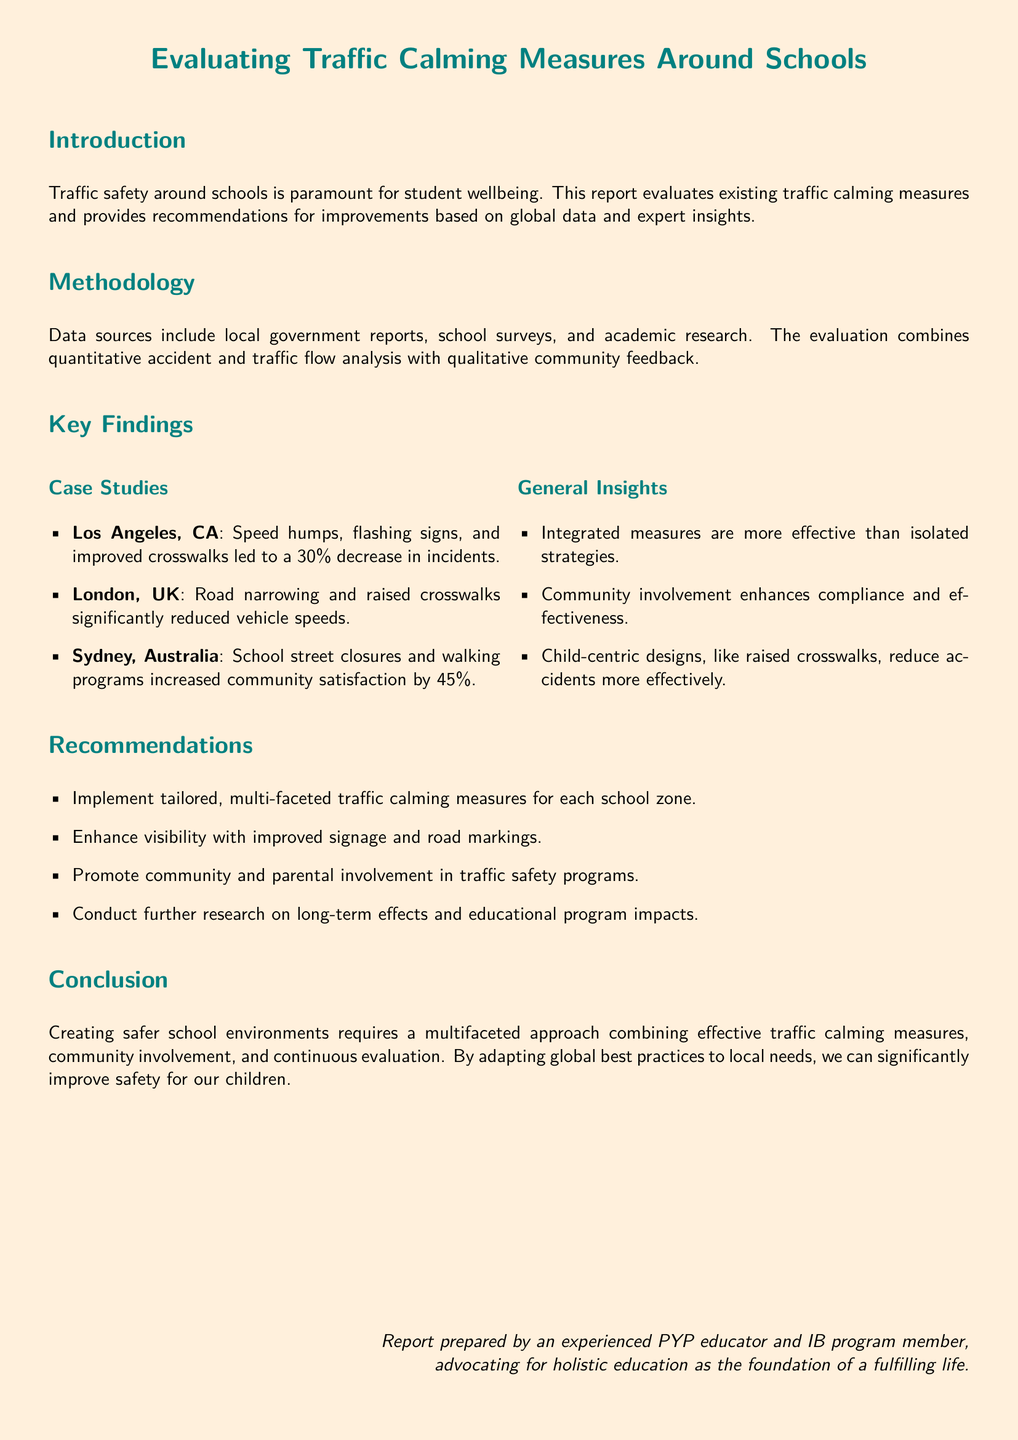What is the main focus of the report? The report focuses on traffic safety around schools and evaluates existing traffic calming measures.
Answer: Traffic safety around schools What city reported a 30% decrease in incidents? The city mentioned in the case study that saw a 30% decrease in incidents is Los Angeles, CA.
Answer: Los Angeles, CA Which country implemented raised crosswalks to reduce vehicle speeds? The case study detailing raised crosswalks as an effective measure is from London, UK.
Answer: London, UK What percentage increase in community satisfaction was reported in Sydney, Australia? The document states that community satisfaction increased by 45% in Sydney, Australia.
Answer: 45% What type of traffic calming measures does the report recommend implementing? The report recommends implementing tailored, multi-faceted traffic calming measures for each school zone.
Answer: Tailored, multi-faceted traffic calming measures What is the document's conclusion regarding safety improvements? The conclusion emphasizes that creating safer school environments requires a multifaceted approach.
Answer: Multifaceted approach What aspect enhances the compliance and effectiveness of traffic measures? Community involvement is identified as enhancing compliance and effectiveness.
Answer: Community involvement What methodology was used for the evaluation in the report? The evaluation uses a combination of quantitative accident and traffic flow analysis with qualitative community feedback.
Answer: Quantitative and qualitative analysis 